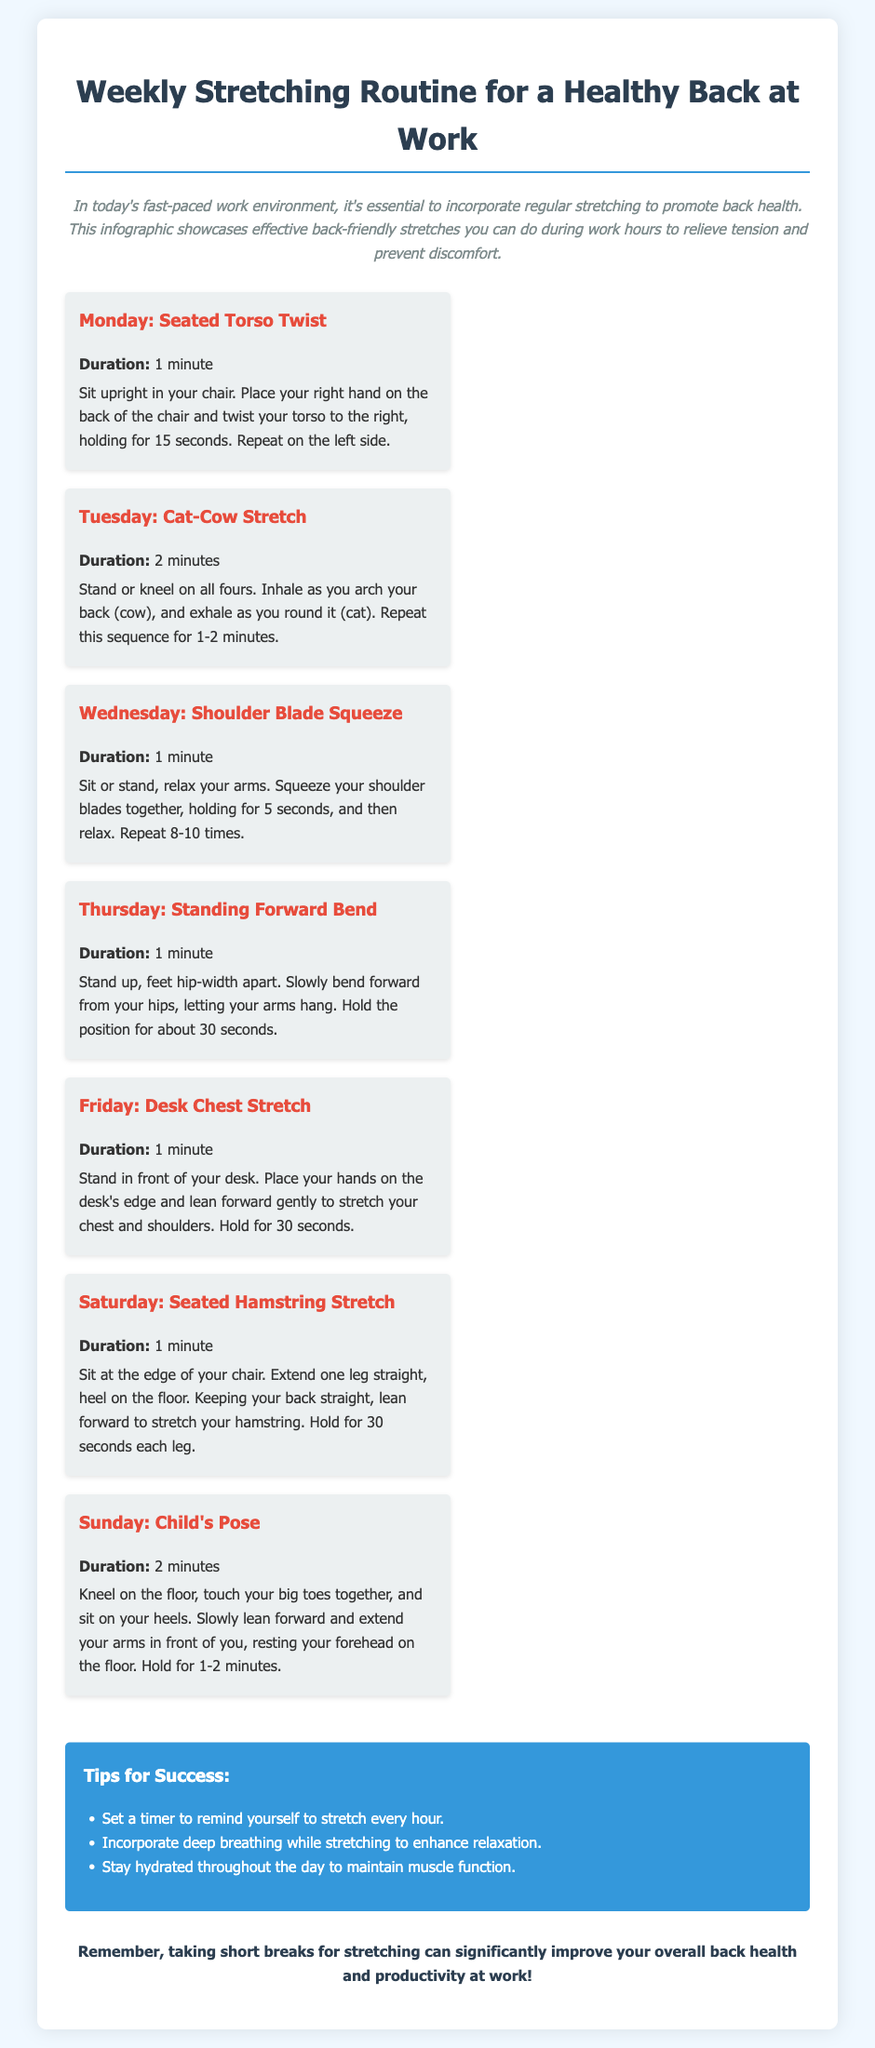What is the title of the document? The title is explicitly mentioned at the top of the document in a prominent position.
Answer: Weekly Stretching Routine for a Healthy Back at Work What exercise is suggested for Monday? The exercise is listed under the Monday section in the schedule of the document.
Answer: Seated Torso Twist How long should the Cat-Cow Stretch be performed? The duration is specified in the description of the exercise for Tuesday.
Answer: 2 minutes What should you do for the Shoulder Blade Squeeze? The actions are provided clearly in the Wednesday section.
Answer: Squeeze shoulder blades together Which exercise is recommended on Saturday? The Saturday exercise is outlined in its dedicated section of the schedule.
Answer: Seated Hamstring Stretch What is one tip for success mentioned in the document? The tips are listed in a specific section dedicated to success strategies.
Answer: Set a timer to remind yourself to stretch every hour How many minutes is the Child's Pose held for? The duration is stated in the description of the exercise for Sunday.
Answer: 2 minutes How many different exercises are listed for the week? The total number is indicated by the number of sections in the weekly schedule.
Answer: 7 exercises Which day includes a stretch for the chest and shoulders? The specific exercise day is identified in the Friday section of the document.
Answer: Friday: Desk Chest Stretch 